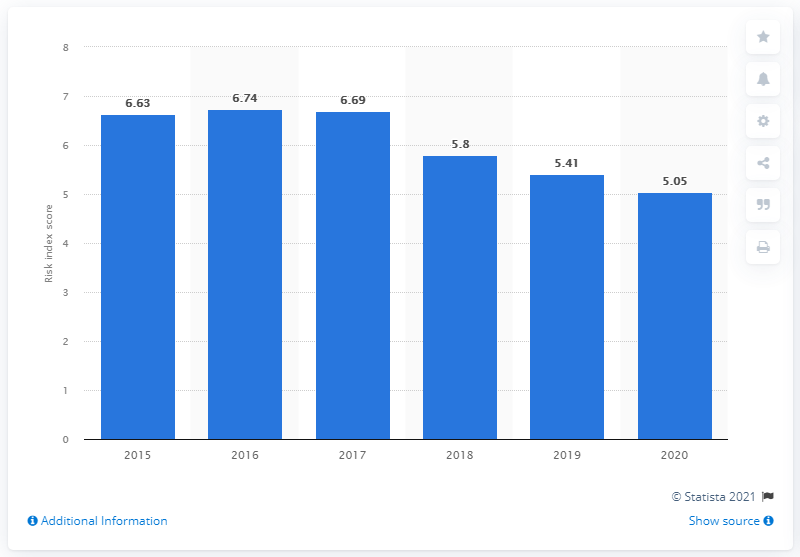Outline some significant characteristics in this image. The Dominican Republic's score was 5.05. In 2016, the Dominican Republic's score was 6.74. 